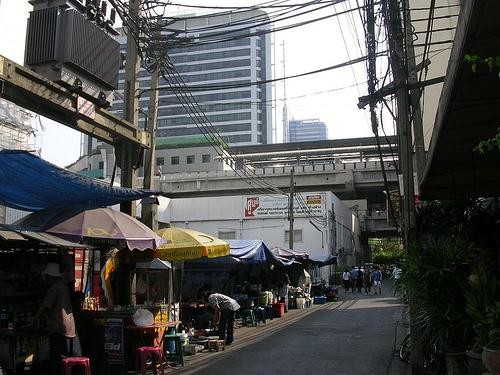Why are there tarps and umbrellas? market 